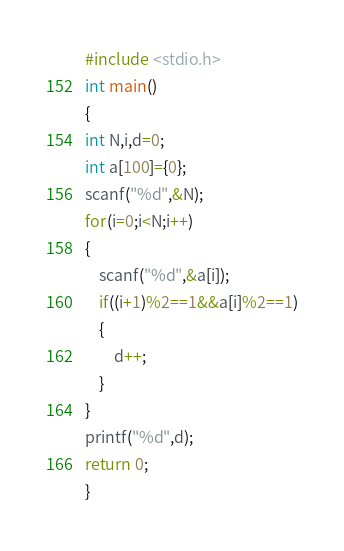<code> <loc_0><loc_0><loc_500><loc_500><_C_>#include <stdio.h>
int main()
{
int N,i,d=0;
int a[100]={0};
scanf("%d",&N);
for(i=0;i<N;i++)
{
    scanf("%d",&a[i]);
    if((i+1)%2==1&&a[i]%2==1)
    {
        d++;
    }
}
printf("%d",d);
return 0;
}</code> 